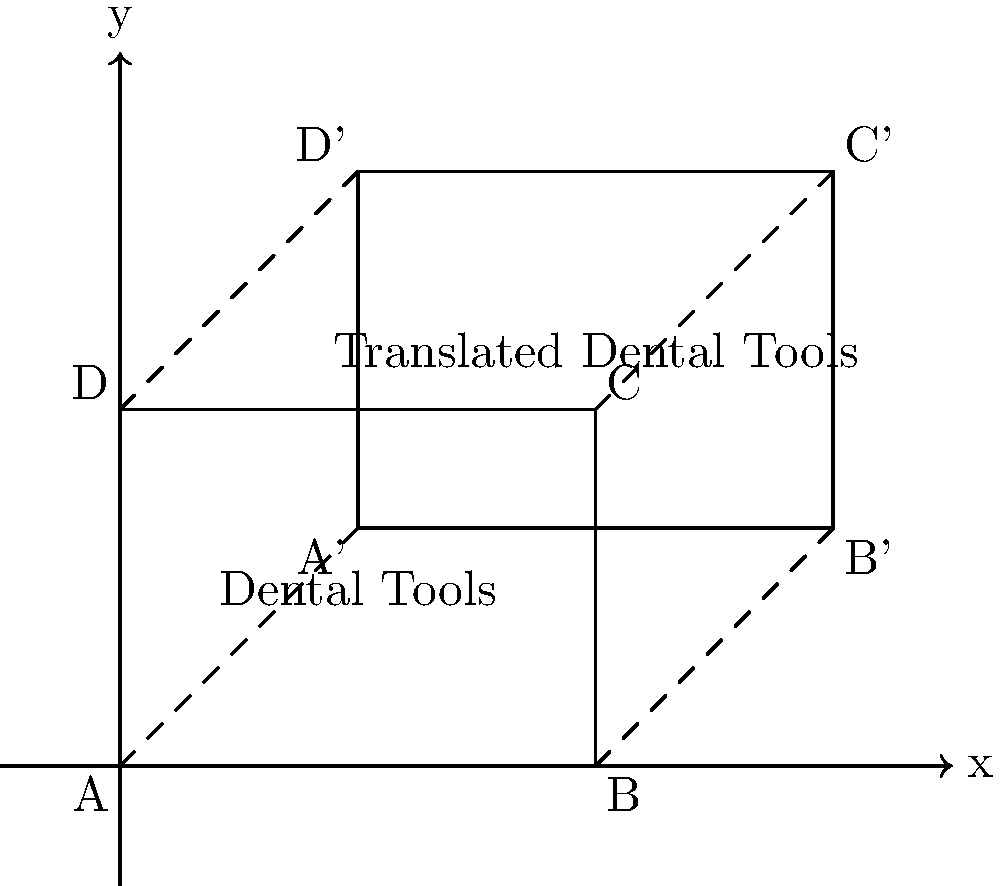In your dental office, you have a set of dental tools represented by rectangle ABCD. You decide to move these tools to a new location in the office. The new position is represented by rectangle A'B'C'D'. What is the translation vector that describes this movement of the dental tools? To find the translation vector, we need to determine how far the original rectangle ABCD has moved horizontally and vertically to reach its new position A'B'C'D'. We can do this by comparing the coordinates of any corresponding pair of points.

Let's use points A and A':

1. Point A is at (0,0)
2. Point A' is at (2,2)

To get from A to A':
- Horizontal movement: 2 units to the right
- Vertical movement: 2 units up

Therefore, the translation can be described as a movement of 2 units right and 2 units up.

In vector notation, this is represented as $\vec{v} = \langle 2, 2 \rangle$.

We can verify this with other corresponding points:
- B(4,0) to B'(6,2): 2 units right, 2 units up
- C(4,3) to C'(6,5): 2 units right, 2 units up
- D(0,3) to D'(2,5): 2 units right, 2 units up

All points confirm the same translation vector.
Answer: $\langle 2, 2 \rangle$ 